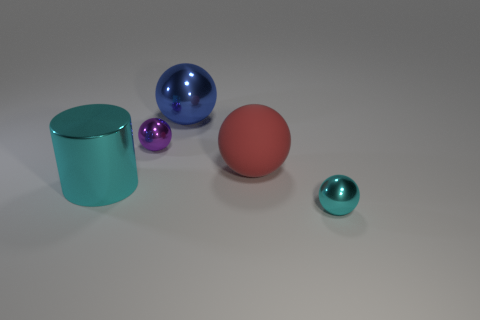Is the material of the cyan object that is left of the big red object the same as the blue thing?
Keep it short and to the point. Yes. There is a tiny shiny object that is to the right of the small sphere that is on the left side of the small metal ball that is to the right of the blue metallic ball; what shape is it?
Your answer should be very brief. Sphere. Are there any red spheres that have the same size as the cyan cylinder?
Make the answer very short. Yes. The purple metal thing is what size?
Give a very brief answer. Small. How many other spheres have the same size as the cyan sphere?
Provide a succinct answer. 1. Are there fewer big cyan metal cylinders left of the large rubber sphere than objects that are behind the large shiny cylinder?
Your response must be concise. Yes. What size is the cyan thing that is on the left side of the cyan object that is on the right side of the cyan shiny object left of the blue object?
Provide a short and direct response. Large. What is the size of the metal thing that is both in front of the purple sphere and right of the tiny purple metal ball?
Your response must be concise. Small. The tiny thing that is in front of the big shiny thing that is on the left side of the big blue object is what shape?
Offer a terse response. Sphere. Are there any other things that have the same color as the shiny cylinder?
Your answer should be very brief. Yes. 